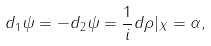<formula> <loc_0><loc_0><loc_500><loc_500>d _ { 1 } \psi = - d _ { 2 } \psi = \frac { 1 } { i } d \rho | _ { X } = \alpha ,</formula> 